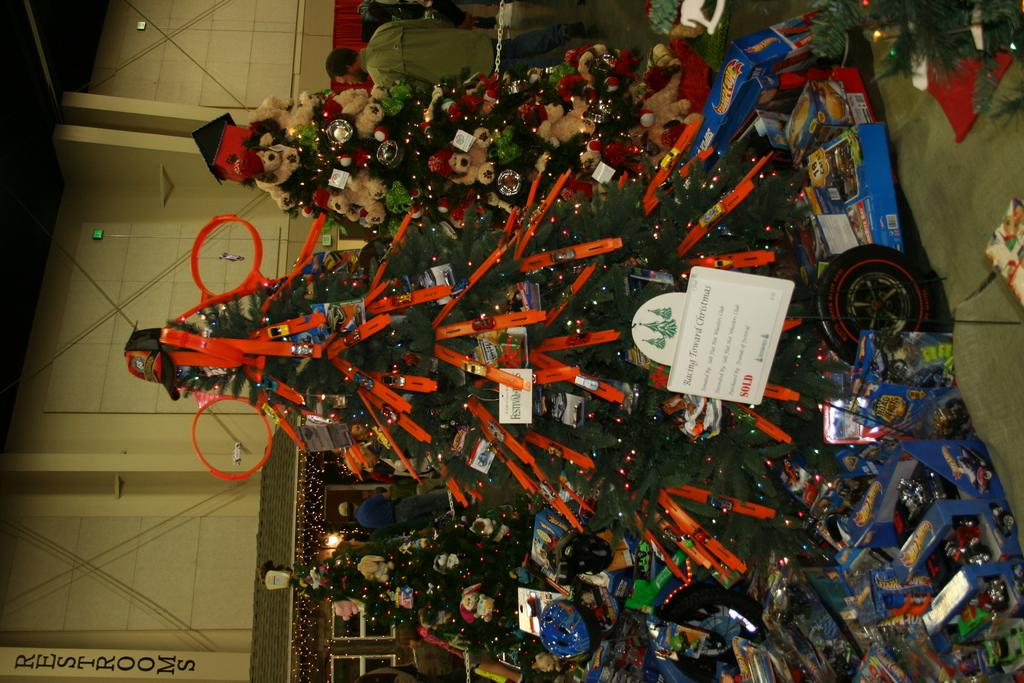What type of decorative items can be seen in the image? There are Christmas trees with decorative items in the image. What is the board with a stand used for? The board with a stand is not explicitly mentioned in the facts, so we cannot determine its purpose from the information provided. What type of items are present in the image besides the Christmas trees? There are cards and toys in boxes visible in the image. Can you describe the background of the image? In the background, there are people visible, as well as a chain, a wall, wires, lights, and windows. What type of self-care routine is being practiced in the image? There is no indication of a self-care routine in the image, as it primarily features Christmas trees and related decorations. What type of cord is visible in the image? There is no mention of a cord in the provided facts, so we cannot determine if one is present in the image. 